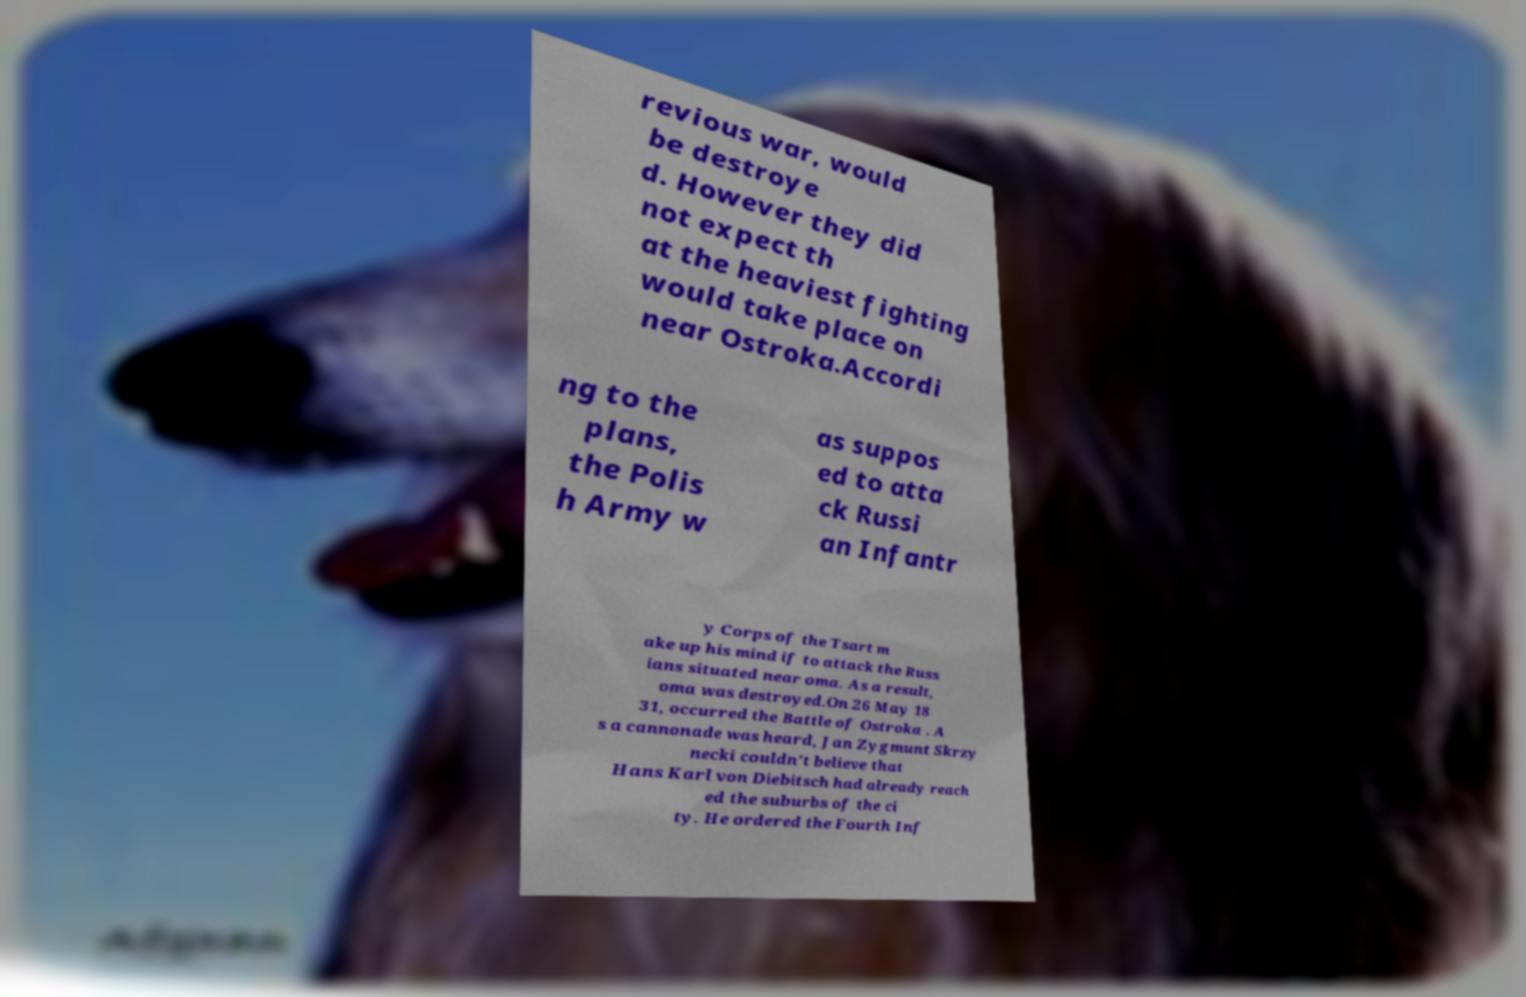Please read and relay the text visible in this image. What does it say? revious war, would be destroye d. However they did not expect th at the heaviest fighting would take place on near Ostroka.Accordi ng to the plans, the Polis h Army w as suppos ed to atta ck Russi an Infantr y Corps of the Tsart m ake up his mind if to attack the Russ ians situated near oma. As a result, oma was destroyed.On 26 May 18 31, occurred the Battle of Ostroka . A s a cannonade was heard, Jan Zygmunt Skrzy necki couldn't believe that Hans Karl von Diebitsch had already reach ed the suburbs of the ci ty. He ordered the Fourth Inf 